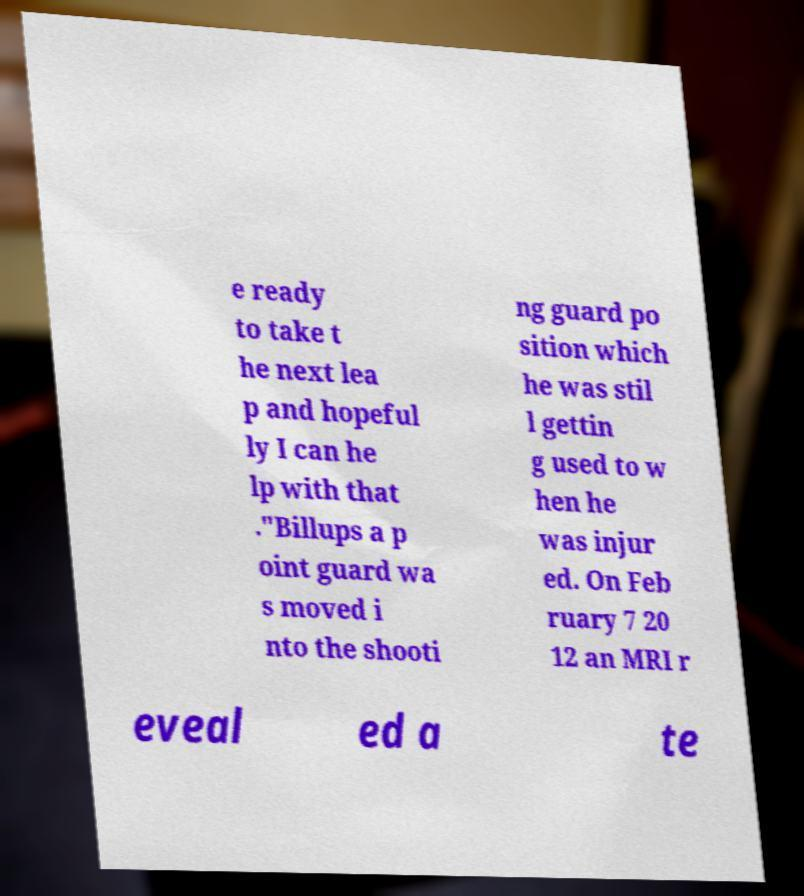Could you extract and type out the text from this image? e ready to take t he next lea p and hopeful ly I can he lp with that ."Billups a p oint guard wa s moved i nto the shooti ng guard po sition which he was stil l gettin g used to w hen he was injur ed. On Feb ruary 7 20 12 an MRI r eveal ed a te 